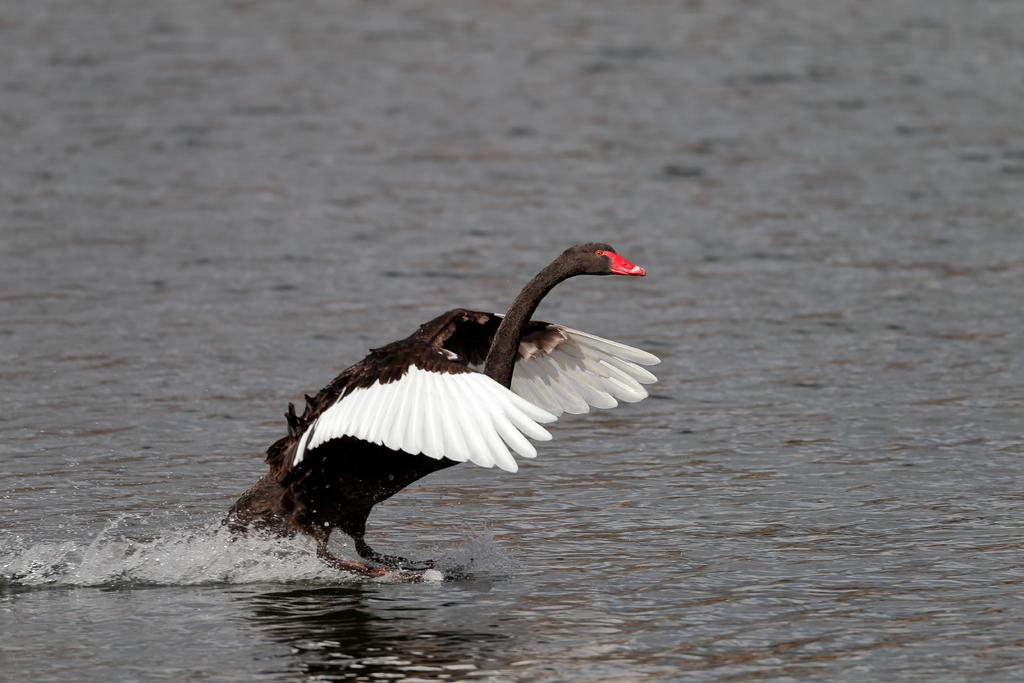What is the main subject in the center of the image? There is a swan in the center of the image. What is the swan's location in relation to the water? The swan is on the water surface. What type of environment is depicted in the image? There is water visible in the image. What letters are written on the notebook in the image? There is no notebook present in the image, so no letters can be observed. 